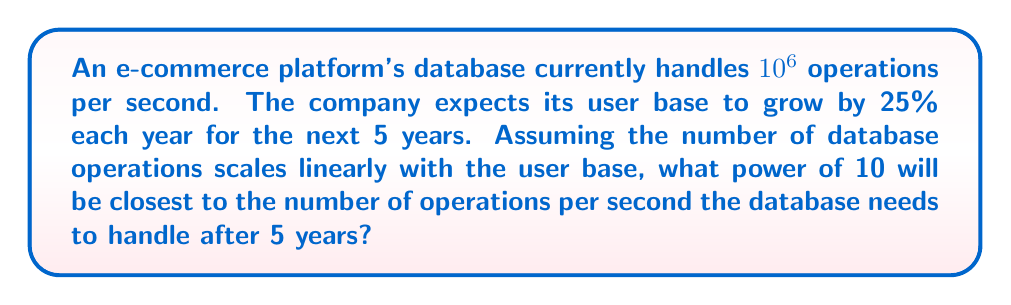What is the answer to this math problem? Let's approach this step-by-step:

1) First, we need to calculate the growth factor after 5 years:
   Growth factor = $(1 + 0.25)^5 = 1.25^5 \approx 3.0518$

2) Now, we can calculate the number of operations after 5 years:
   Final operations = $10^6 \times 3.0518 \approx 3.0518 \times 10^6$

3) We need to express this in the form $10^x$:
   $3.0518 \times 10^6 = 10^x$

4) Taking logarithms of both sides:
   $\log(3.0518 \times 10^6) = x$

5) Using the logarithm product rule:
   $\log(3.0518) + \log(10^6) = x$

6) Simplify:
   $0.4845 + 6 = x$

7) Calculate:
   $x \approx 6.4845$

8) The closest integer power of 10 is 6, as $10^6 = 1,000,000$ and $10^7 = 10,000,000$.
Answer: 6 